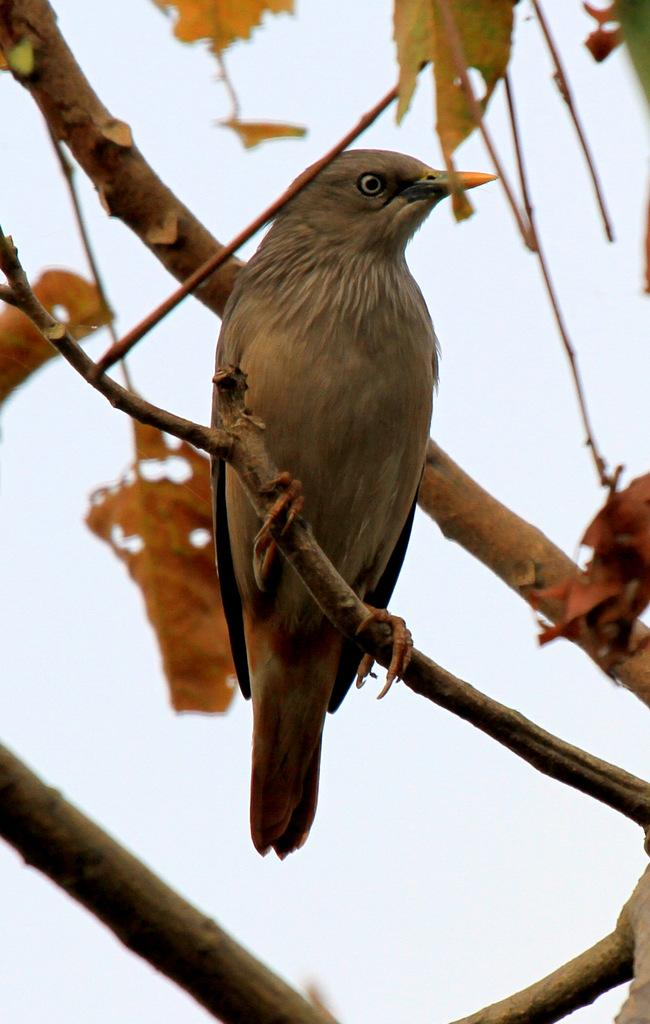What type of animal can be seen in the image? There is a bird in the image. What is the bird doing in the image? The bird is standing in the image. What type of vegetation is present in the image? There are leaves in the image. What part of a tree is visible in the image? Tree trunks are visible in the image. What time of day is it in the image, and how many sheep are present? The time of day is not mentioned in the image, and there are no sheep present in the image. 